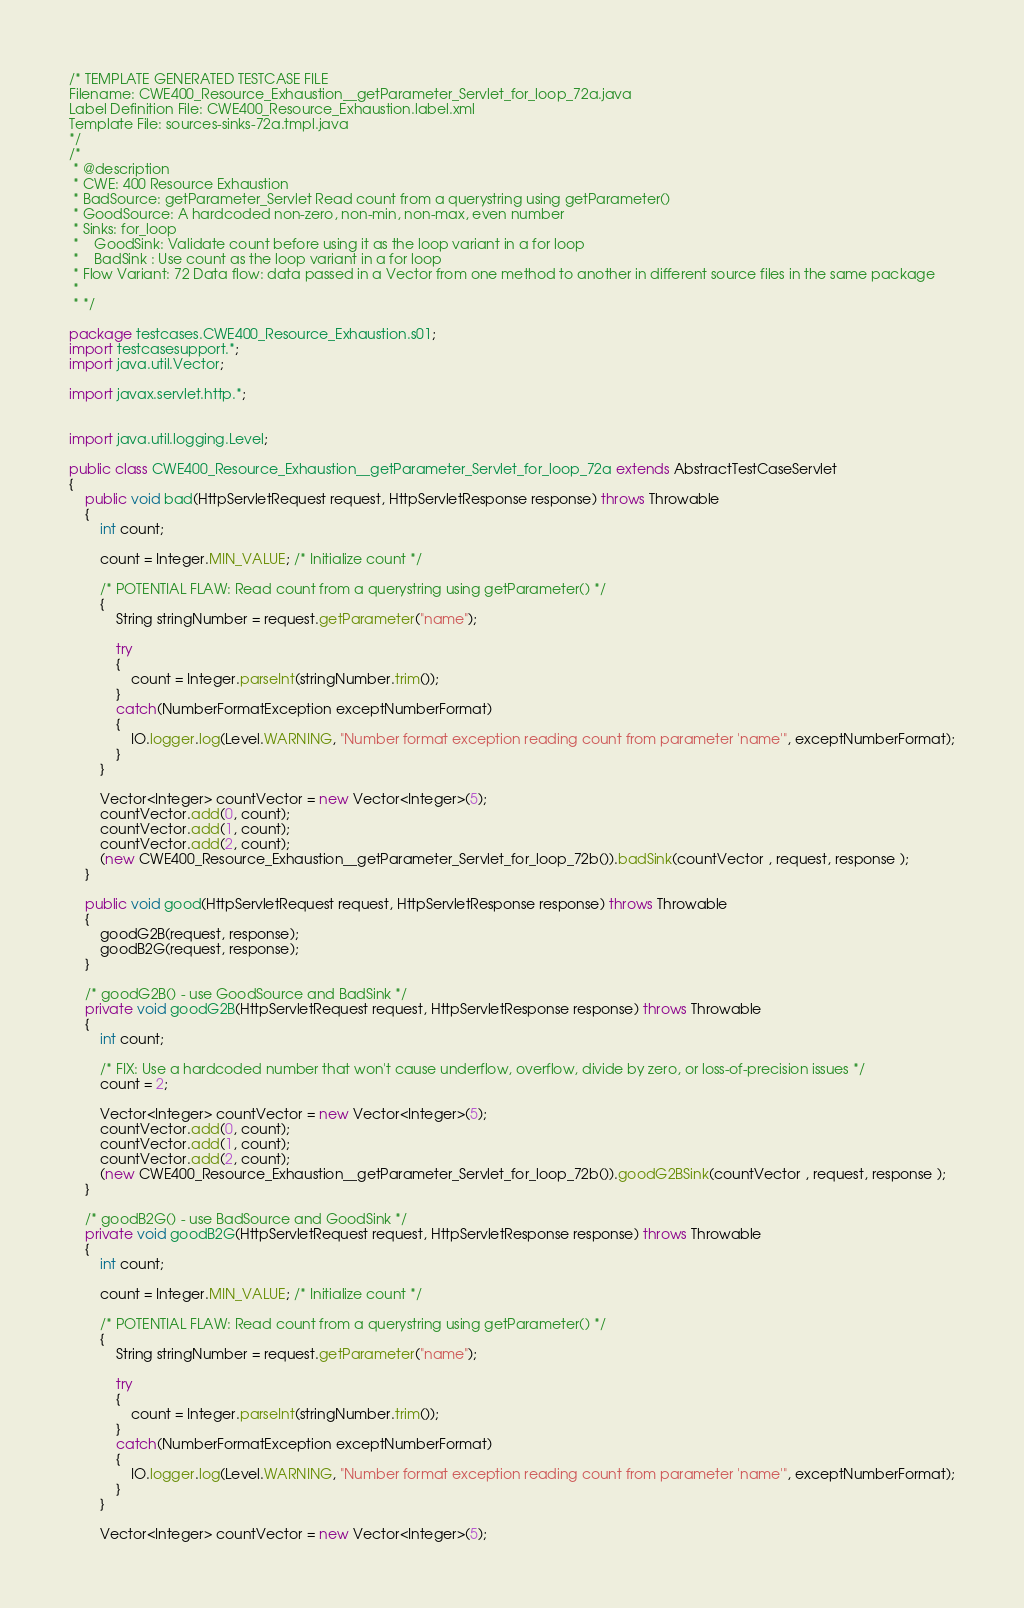<code> <loc_0><loc_0><loc_500><loc_500><_Java_>/* TEMPLATE GENERATED TESTCASE FILE
Filename: CWE400_Resource_Exhaustion__getParameter_Servlet_for_loop_72a.java
Label Definition File: CWE400_Resource_Exhaustion.label.xml
Template File: sources-sinks-72a.tmpl.java
*/
/*
 * @description
 * CWE: 400 Resource Exhaustion
 * BadSource: getParameter_Servlet Read count from a querystring using getParameter()
 * GoodSource: A hardcoded non-zero, non-min, non-max, even number
 * Sinks: for_loop
 *    GoodSink: Validate count before using it as the loop variant in a for loop
 *    BadSink : Use count as the loop variant in a for loop
 * Flow Variant: 72 Data flow: data passed in a Vector from one method to another in different source files in the same package
 *
 * */

package testcases.CWE400_Resource_Exhaustion.s01;
import testcasesupport.*;
import java.util.Vector;

import javax.servlet.http.*;


import java.util.logging.Level;

public class CWE400_Resource_Exhaustion__getParameter_Servlet_for_loop_72a extends AbstractTestCaseServlet
{
    public void bad(HttpServletRequest request, HttpServletResponse response) throws Throwable
    {
        int count;

        count = Integer.MIN_VALUE; /* Initialize count */

        /* POTENTIAL FLAW: Read count from a querystring using getParameter() */
        {
            String stringNumber = request.getParameter("name");

            try
            {
                count = Integer.parseInt(stringNumber.trim());
            }
            catch(NumberFormatException exceptNumberFormat)
            {
                IO.logger.log(Level.WARNING, "Number format exception reading count from parameter 'name'", exceptNumberFormat);
            }
        }

        Vector<Integer> countVector = new Vector<Integer>(5);
        countVector.add(0, count);
        countVector.add(1, count);
        countVector.add(2, count);
        (new CWE400_Resource_Exhaustion__getParameter_Servlet_for_loop_72b()).badSink(countVector , request, response );
    }

    public void good(HttpServletRequest request, HttpServletResponse response) throws Throwable
    {
        goodG2B(request, response);
        goodB2G(request, response);
    }

    /* goodG2B() - use GoodSource and BadSink */
    private void goodG2B(HttpServletRequest request, HttpServletResponse response) throws Throwable
    {
        int count;

        /* FIX: Use a hardcoded number that won't cause underflow, overflow, divide by zero, or loss-of-precision issues */
        count = 2;

        Vector<Integer> countVector = new Vector<Integer>(5);
        countVector.add(0, count);
        countVector.add(1, count);
        countVector.add(2, count);
        (new CWE400_Resource_Exhaustion__getParameter_Servlet_for_loop_72b()).goodG2BSink(countVector , request, response );
    }

    /* goodB2G() - use BadSource and GoodSink */
    private void goodB2G(HttpServletRequest request, HttpServletResponse response) throws Throwable
    {
        int count;

        count = Integer.MIN_VALUE; /* Initialize count */

        /* POTENTIAL FLAW: Read count from a querystring using getParameter() */
        {
            String stringNumber = request.getParameter("name");

            try
            {
                count = Integer.parseInt(stringNumber.trim());
            }
            catch(NumberFormatException exceptNumberFormat)
            {
                IO.logger.log(Level.WARNING, "Number format exception reading count from parameter 'name'", exceptNumberFormat);
            }
        }

        Vector<Integer> countVector = new Vector<Integer>(5);</code> 